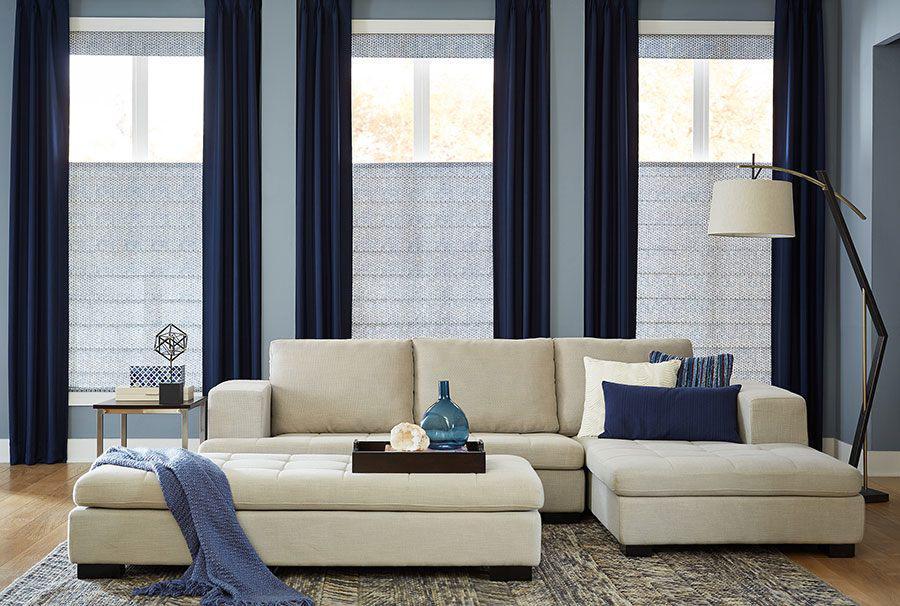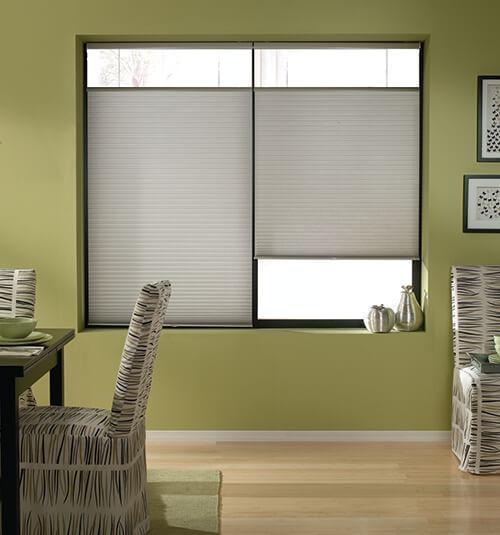The first image is the image on the left, the second image is the image on the right. For the images displayed, is the sentence "There are buildings visible through the windows." factually correct? Answer yes or no. No. The first image is the image on the left, the second image is the image on the right. Given the left and right images, does the statement "One image shows a tufted couch in front of a wide paned window on the left and a narrower window on the right, all with gray shades that don't cover the window tops." hold true? Answer yes or no. No. 